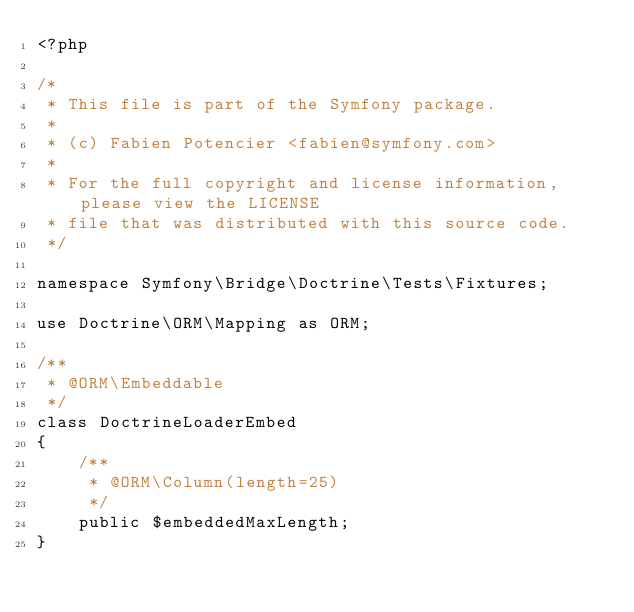<code> <loc_0><loc_0><loc_500><loc_500><_PHP_><?php

/*
 * This file is part of the Symfony package.
 *
 * (c) Fabien Potencier <fabien@symfony.com>
 *
 * For the full copyright and license information, please view the LICENSE
 * file that was distributed with this source code.
 */

namespace Symfony\Bridge\Doctrine\Tests\Fixtures;

use Doctrine\ORM\Mapping as ORM;

/**
 * @ORM\Embeddable
 */
class DoctrineLoaderEmbed
{
    /**
     * @ORM\Column(length=25)
     */
    public $embeddedMaxLength;
}
</code> 